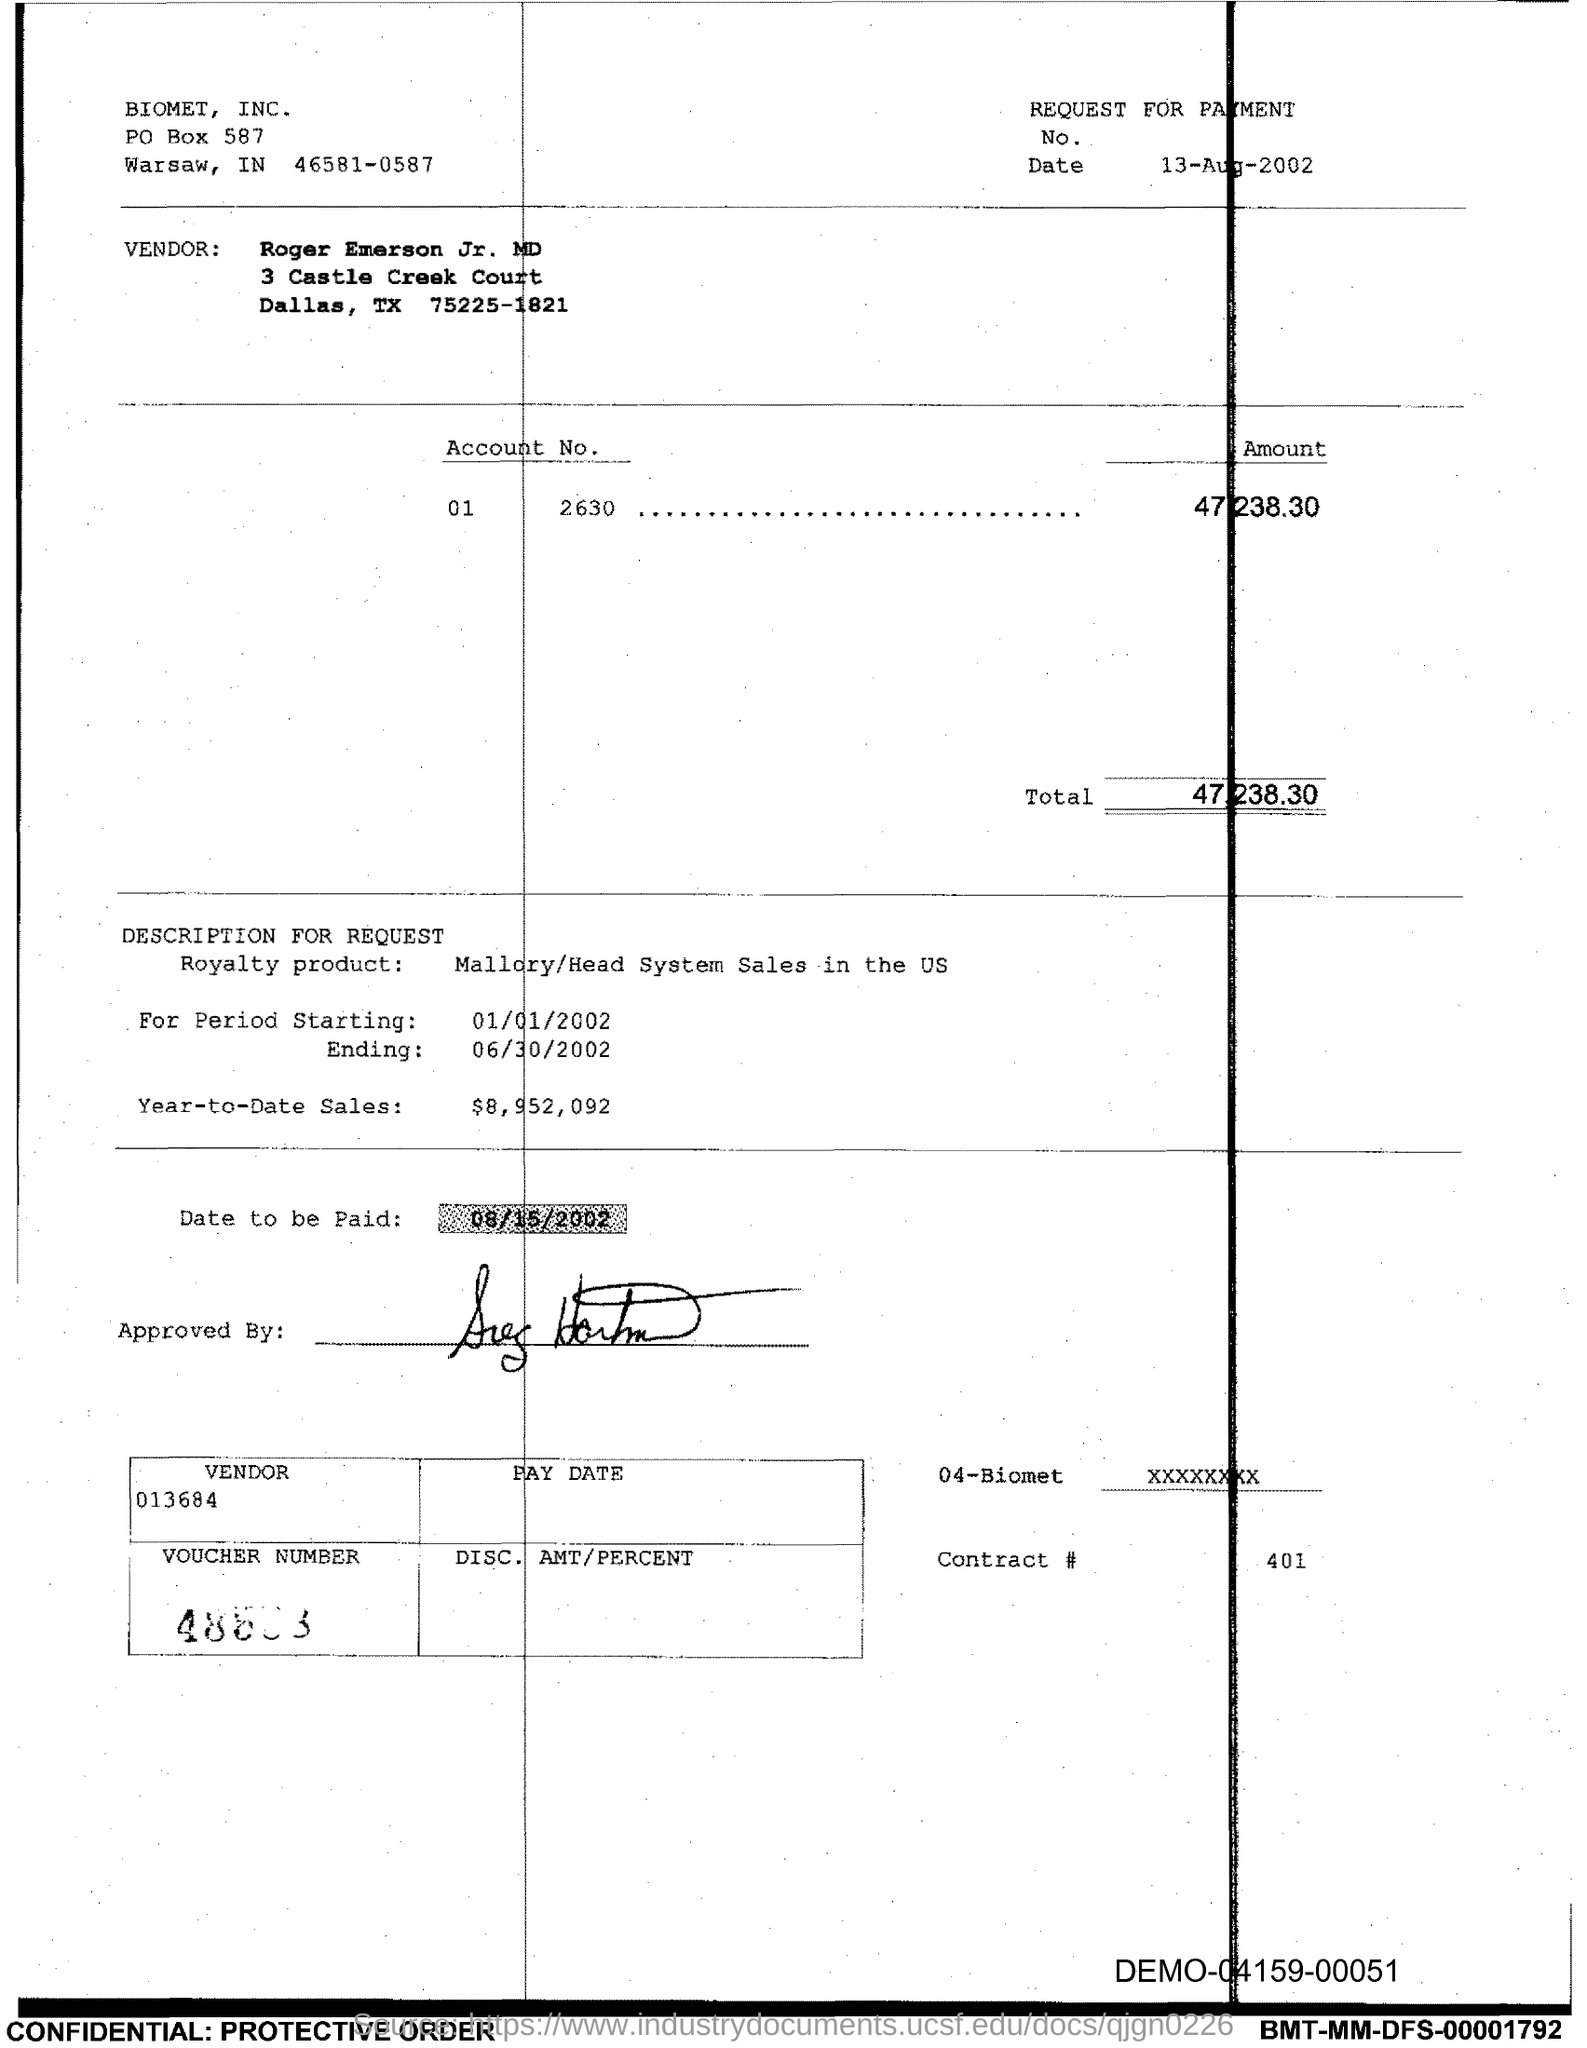Highlight a few significant elements in this photo. The PO Box number mentioned in the document is 587. The total amount is 47,238.30. 